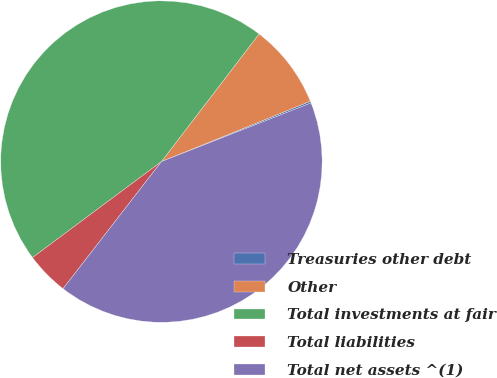Convert chart. <chart><loc_0><loc_0><loc_500><loc_500><pie_chart><fcel>Treasuries other debt<fcel>Other<fcel>Total investments at fair<fcel>Total liabilities<fcel>Total net assets ^(1)<nl><fcel>0.18%<fcel>8.48%<fcel>45.58%<fcel>4.33%<fcel>41.43%<nl></chart> 